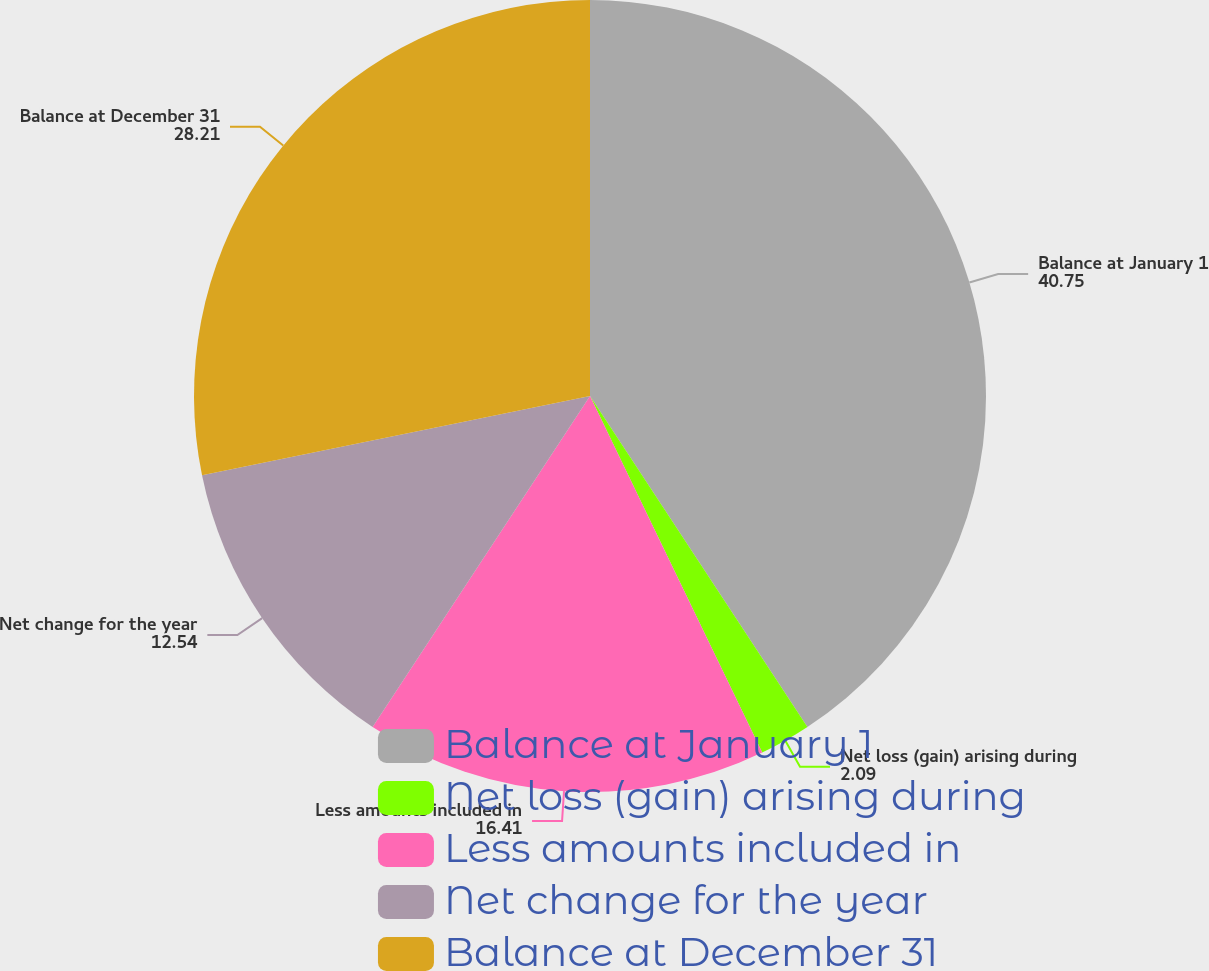Convert chart to OTSL. <chart><loc_0><loc_0><loc_500><loc_500><pie_chart><fcel>Balance at January 1<fcel>Net loss (gain) arising during<fcel>Less amounts included in<fcel>Net change for the year<fcel>Balance at December 31<nl><fcel>40.75%<fcel>2.09%<fcel>16.41%<fcel>12.54%<fcel>28.21%<nl></chart> 